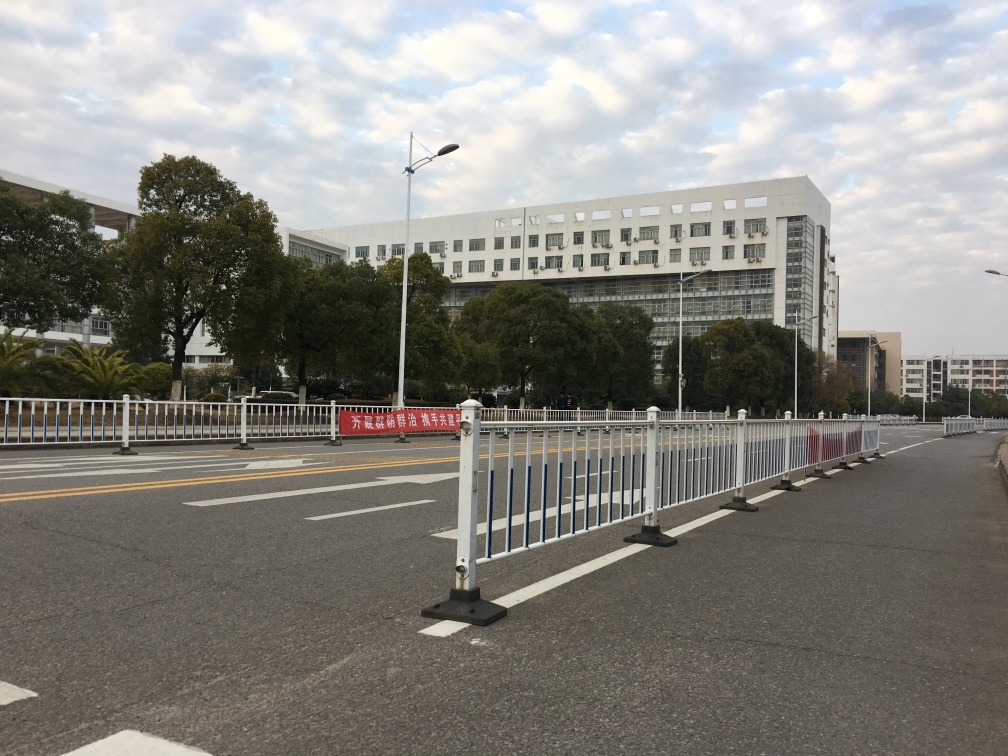Is this area typically busy, and how can you tell? While the image does not show crowds or traffic, the presence of multiple traffic lanes, a pedestrian guardrail, and a large building hint that this area could be busy during peak hours. The absence of people and vehicles at the moment suggests it might be a non-peak time or the area may be experiencing a temporary decrease in activity. 